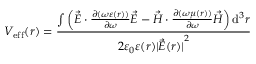Convert formula to latex. <formula><loc_0><loc_0><loc_500><loc_500>V _ { e f f } ( r ) = \frac { \int \left ( \vec { E } \cdot \frac { \partial ( \omega \varepsilon ( r ) ) } { \partial \omega } \vec { E } - \vec { H } \cdot \frac { \partial ( \omega \mu ( r ) ) } { \partial \omega } \vec { H } \right ) d ^ { 3 } r } { 2 \varepsilon _ { 0 } \varepsilon ( r ) { | \vec { E } ( r ) | } ^ { 2 } }</formula> 